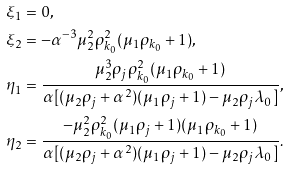Convert formula to latex. <formula><loc_0><loc_0><loc_500><loc_500>& \xi _ { 1 } = 0 , \\ & \xi _ { 2 } = - \alpha ^ { - 3 } \mu ^ { 2 } _ { 2 } \rho ^ { 2 } _ { k _ { 0 } } ( \mu _ { 1 } \rho _ { k _ { 0 } } + 1 ) , \\ & \eta _ { 1 } = \frac { \mu ^ { 3 } _ { 2 } \rho _ { j } \rho ^ { 2 } _ { k _ { 0 } } ( \mu _ { 1 } \rho _ { k _ { 0 } } + 1 ) } { \alpha [ ( \mu _ { 2 } \rho _ { j } + \alpha ^ { 2 } ) ( \mu _ { 1 } \rho _ { j } + 1 ) - \mu _ { 2 } \rho _ { j } \lambda _ { 0 } ] } , \\ & \eta _ { 2 } = \frac { - \mu ^ { 2 } _ { 2 } \rho ^ { 2 } _ { k _ { 0 } } ( \mu _ { 1 } \rho _ { j } + 1 ) ( \mu _ { 1 } \rho _ { k _ { 0 } } + 1 ) } { \alpha [ ( \mu _ { 2 } \rho _ { j } + \alpha ^ { 2 } ) ( \mu _ { 1 } \rho _ { j } + 1 ) - \mu _ { 2 } \rho _ { j } \lambda _ { 0 } ] } .</formula> 